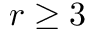Convert formula to latex. <formula><loc_0><loc_0><loc_500><loc_500>r \geq 3</formula> 